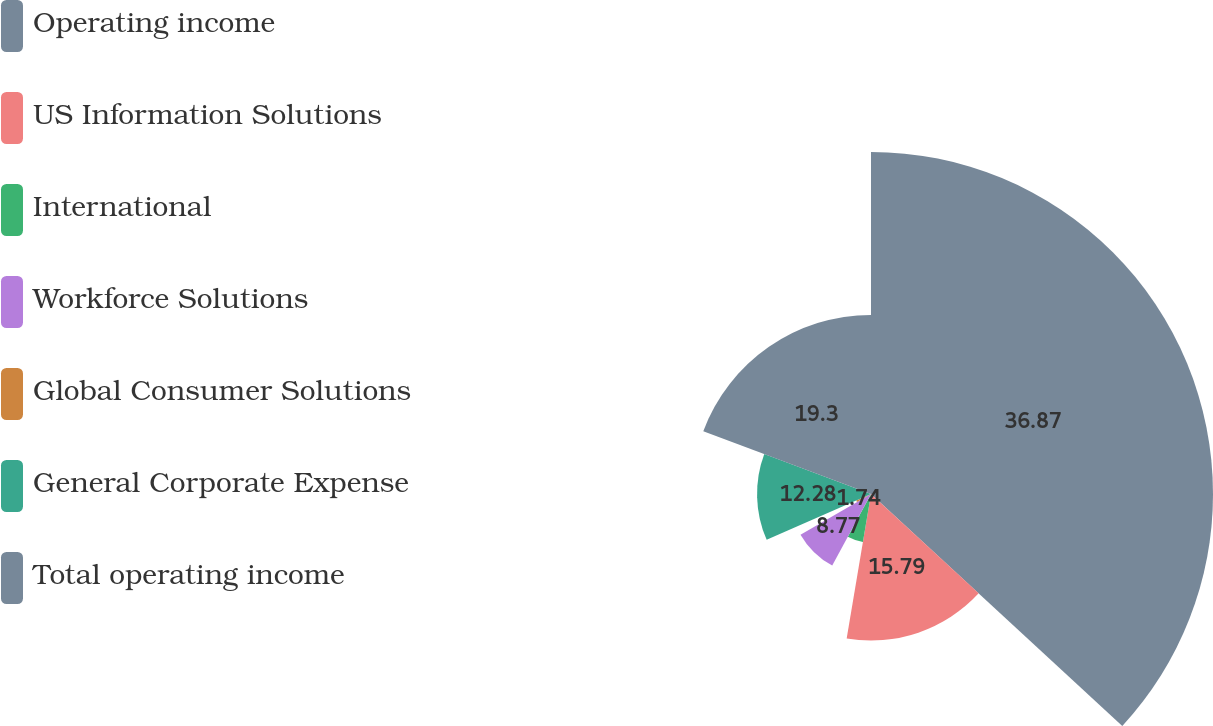Convert chart. <chart><loc_0><loc_0><loc_500><loc_500><pie_chart><fcel>Operating income<fcel>US Information Solutions<fcel>International<fcel>Workforce Solutions<fcel>Global Consumer Solutions<fcel>General Corporate Expense<fcel>Total operating income<nl><fcel>36.86%<fcel>15.79%<fcel>5.25%<fcel>8.77%<fcel>1.74%<fcel>12.28%<fcel>19.3%<nl></chart> 